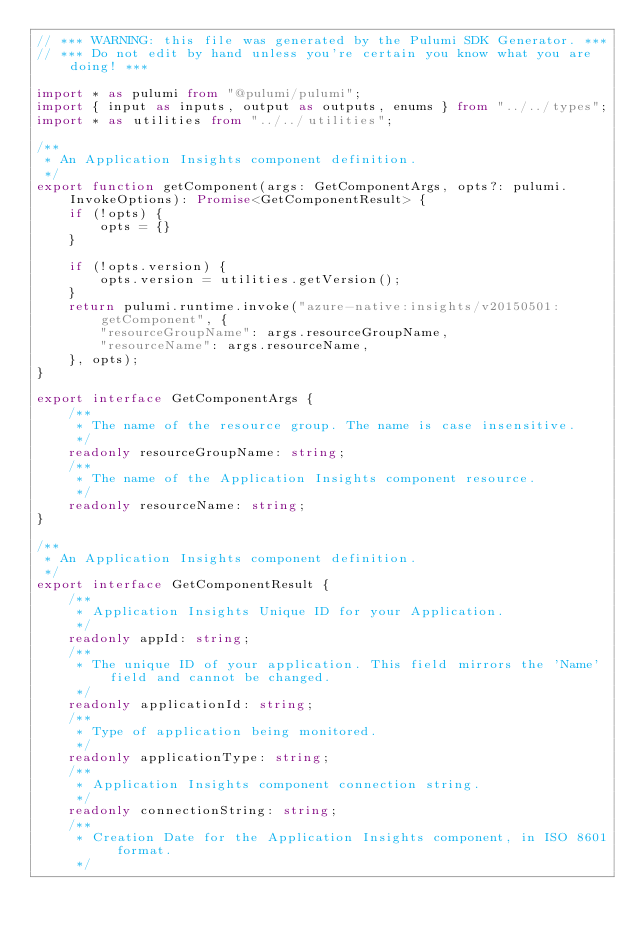Convert code to text. <code><loc_0><loc_0><loc_500><loc_500><_TypeScript_>// *** WARNING: this file was generated by the Pulumi SDK Generator. ***
// *** Do not edit by hand unless you're certain you know what you are doing! ***

import * as pulumi from "@pulumi/pulumi";
import { input as inputs, output as outputs, enums } from "../../types";
import * as utilities from "../../utilities";

/**
 * An Application Insights component definition.
 */
export function getComponent(args: GetComponentArgs, opts?: pulumi.InvokeOptions): Promise<GetComponentResult> {
    if (!opts) {
        opts = {}
    }

    if (!opts.version) {
        opts.version = utilities.getVersion();
    }
    return pulumi.runtime.invoke("azure-native:insights/v20150501:getComponent", {
        "resourceGroupName": args.resourceGroupName,
        "resourceName": args.resourceName,
    }, opts);
}

export interface GetComponentArgs {
    /**
     * The name of the resource group. The name is case insensitive.
     */
    readonly resourceGroupName: string;
    /**
     * The name of the Application Insights component resource.
     */
    readonly resourceName: string;
}

/**
 * An Application Insights component definition.
 */
export interface GetComponentResult {
    /**
     * Application Insights Unique ID for your Application.
     */
    readonly appId: string;
    /**
     * The unique ID of your application. This field mirrors the 'Name' field and cannot be changed.
     */
    readonly applicationId: string;
    /**
     * Type of application being monitored.
     */
    readonly applicationType: string;
    /**
     * Application Insights component connection string.
     */
    readonly connectionString: string;
    /**
     * Creation Date for the Application Insights component, in ISO 8601 format.
     */</code> 